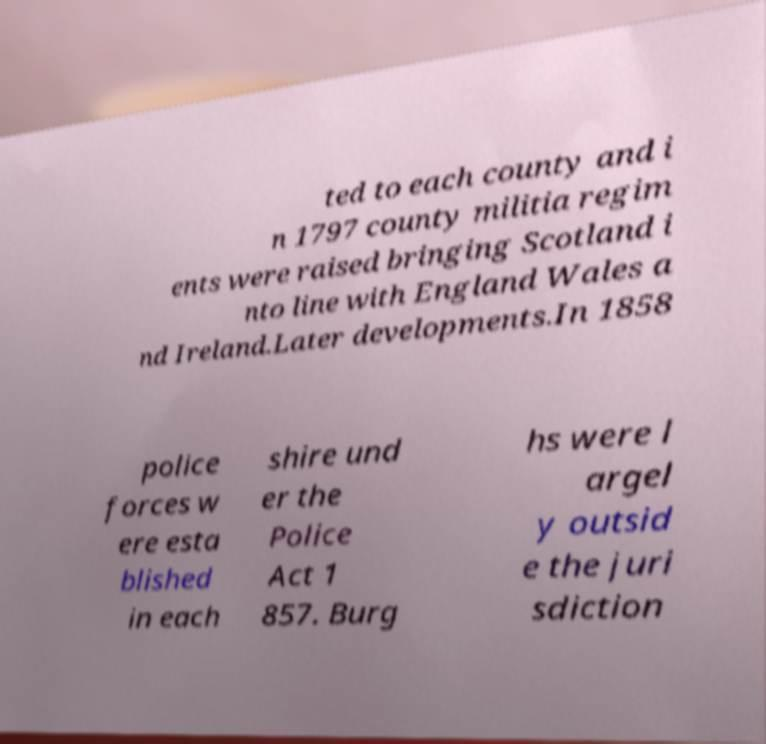For documentation purposes, I need the text within this image transcribed. Could you provide that? ted to each county and i n 1797 county militia regim ents were raised bringing Scotland i nto line with England Wales a nd Ireland.Later developments.In 1858 police forces w ere esta blished in each shire und er the Police Act 1 857. Burg hs were l argel y outsid e the juri sdiction 